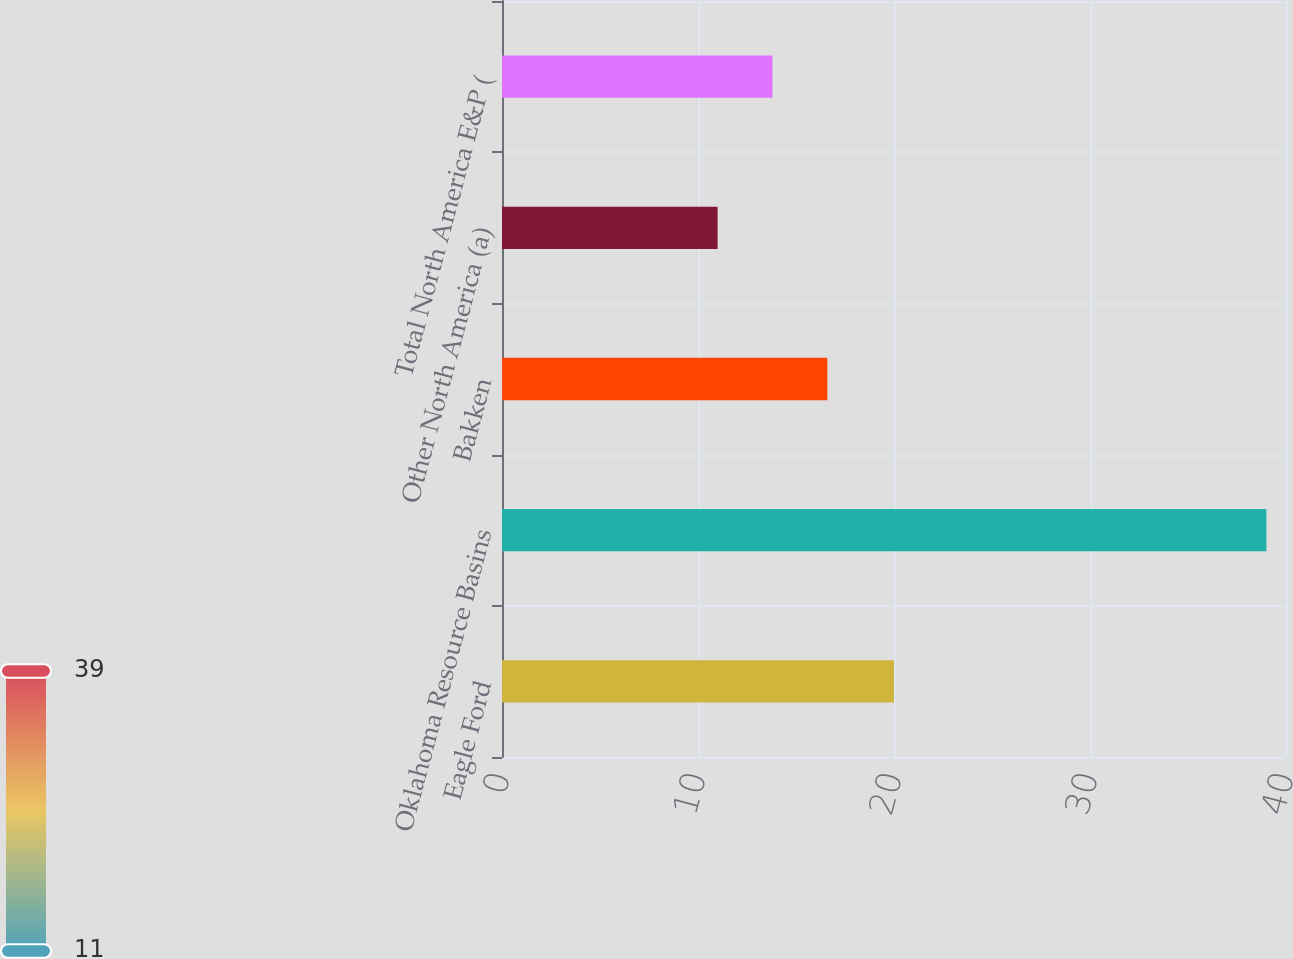Convert chart. <chart><loc_0><loc_0><loc_500><loc_500><bar_chart><fcel>Eagle Ford<fcel>Oklahoma Resource Basins<fcel>Bakken<fcel>Other North America (a)<fcel>Total North America E&P (<nl><fcel>20<fcel>39<fcel>16.6<fcel>11<fcel>13.8<nl></chart> 